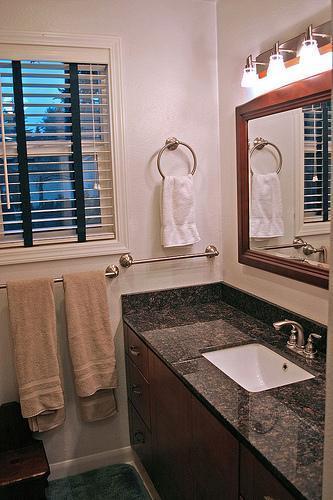How many towels are there?
Give a very brief answer. 3. 